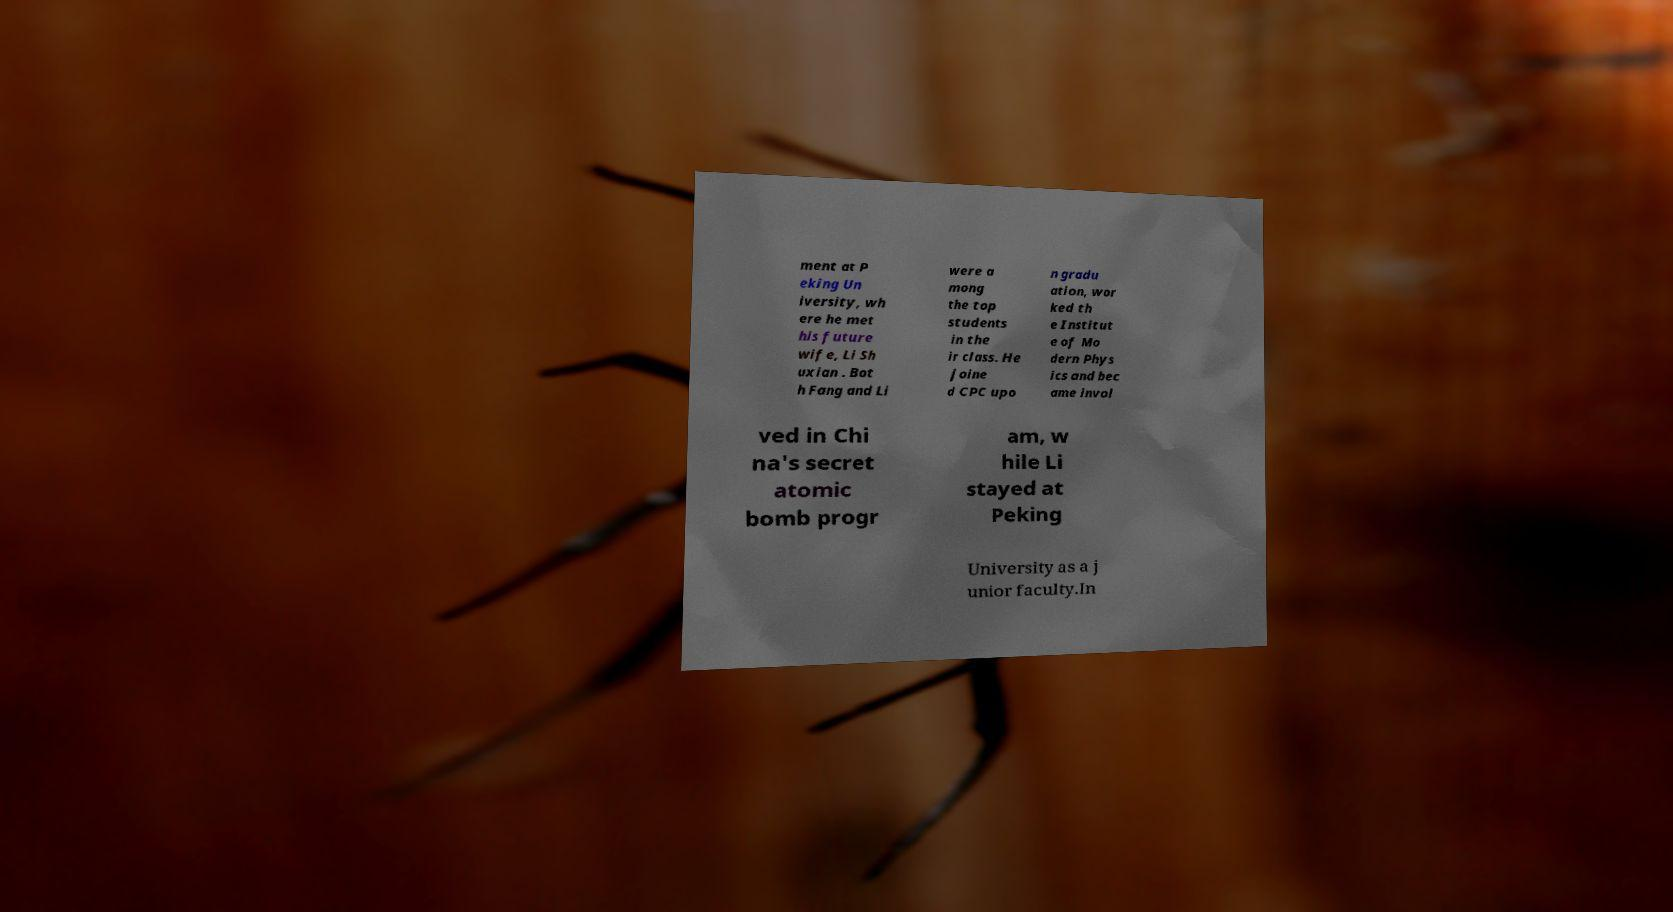For documentation purposes, I need the text within this image transcribed. Could you provide that? ment at P eking Un iversity, wh ere he met his future wife, Li Sh uxian . Bot h Fang and Li were a mong the top students in the ir class. He joine d CPC upo n gradu ation, wor ked th e Institut e of Mo dern Phys ics and bec ame invol ved in Chi na's secret atomic bomb progr am, w hile Li stayed at Peking University as a j unior faculty.In 